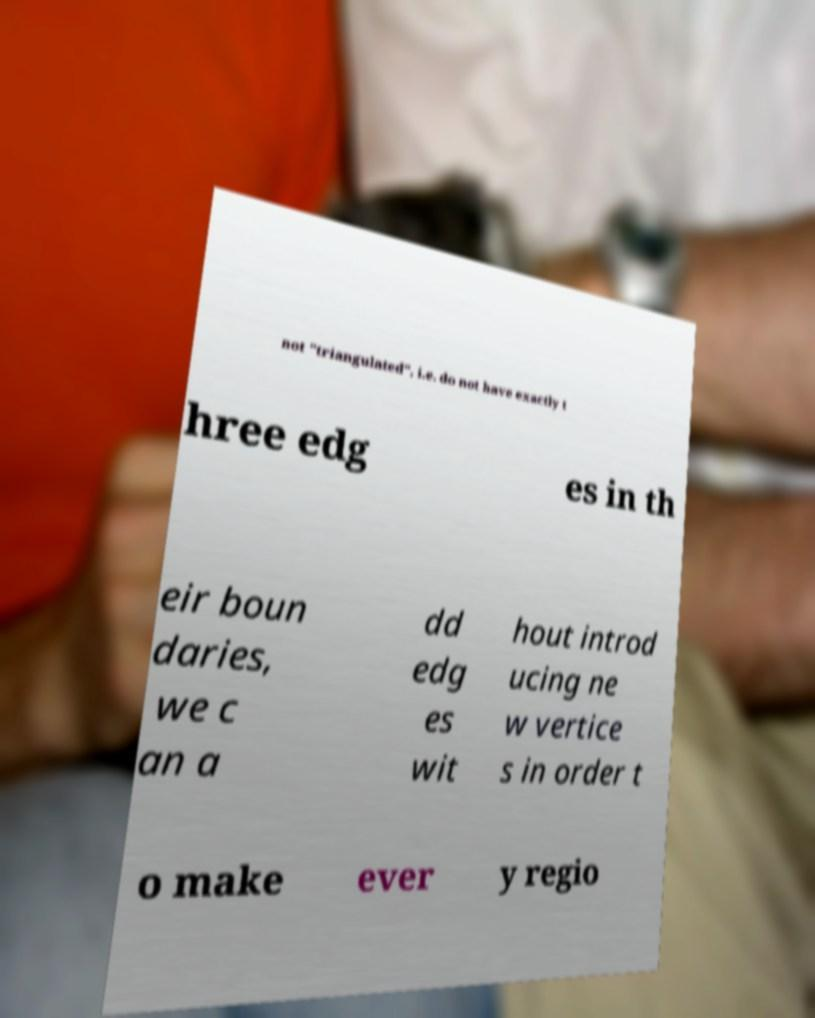Could you assist in decoding the text presented in this image and type it out clearly? not "triangulated", i.e. do not have exactly t hree edg es in th eir boun daries, we c an a dd edg es wit hout introd ucing ne w vertice s in order t o make ever y regio 